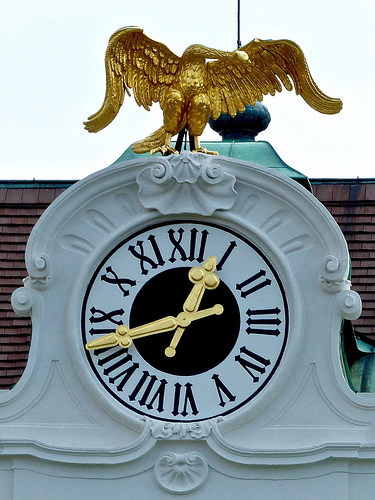<image>
Is there a eagle on the clock? Yes. Looking at the image, I can see the eagle is positioned on top of the clock, with the clock providing support. Where is the golden bird in relation to the clock? Is it on the clock? Yes. Looking at the image, I can see the golden bird is positioned on top of the clock, with the clock providing support. 